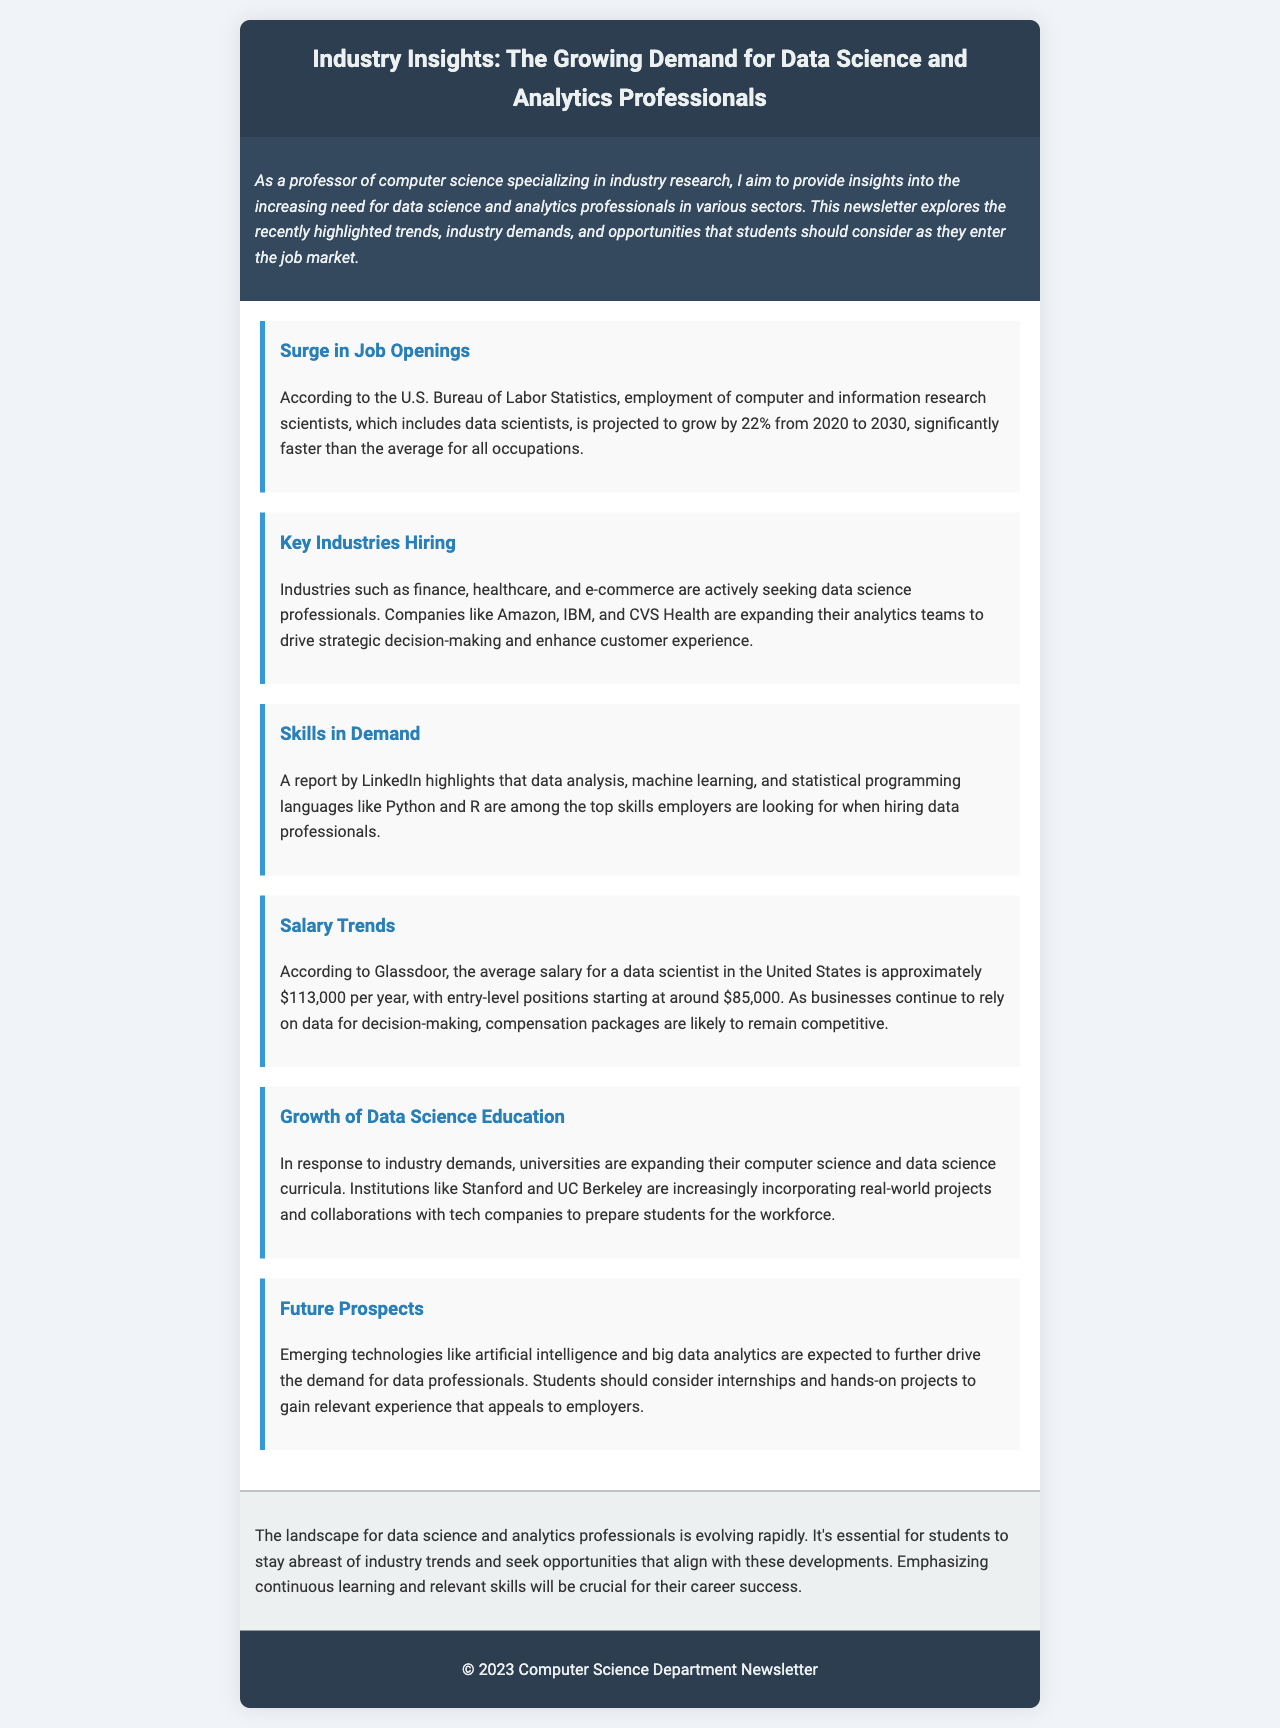What is the projected growth rate for employment of data scientists? The document states that employment of computer and information research scientists, including data scientists, is projected to grow by 22% from 2020 to 2030.
Answer: 22% Which industries are actively seeking data science professionals? The document mentions that industries such as finance, healthcare, and e-commerce are looking for data science professionals.
Answer: Finance, healthcare, e-commerce What are the top skills employers seek in data professionals? According to the report by LinkedIn in the document, skills like data analysis, machine learning, and programming languages like Python and R are in demand.
Answer: Data analysis, machine learning, Python, R What is the average salary for a data scientist in the United States? The document states that the average salary for a data scientist is approximately $113,000 per year.
Answer: $113,000 Which universities are expanding their data science curricula? The document highlights that institutions like Stanford and UC Berkeley are expanding their computer science and data science curricula.
Answer: Stanford, UC Berkeley Why are compensation packages for data professionals expected to remain competitive? The document argues that as businesses continue to rely on data for decision-making, compensation packages are likely to remain competitive.
Answer: Due to reliance on data What is emphasized as crucial for career success in the field of data science? The document concludes that emphasizing continuous learning and relevant skills is essential for career success.
Answer: Continuous learning and relevant skills What type of projects should students consider for gaining relevant experience? The document suggests that students should consider internships and hands-on projects to gain relevant experience.
Answer: Internships and hands-on projects 